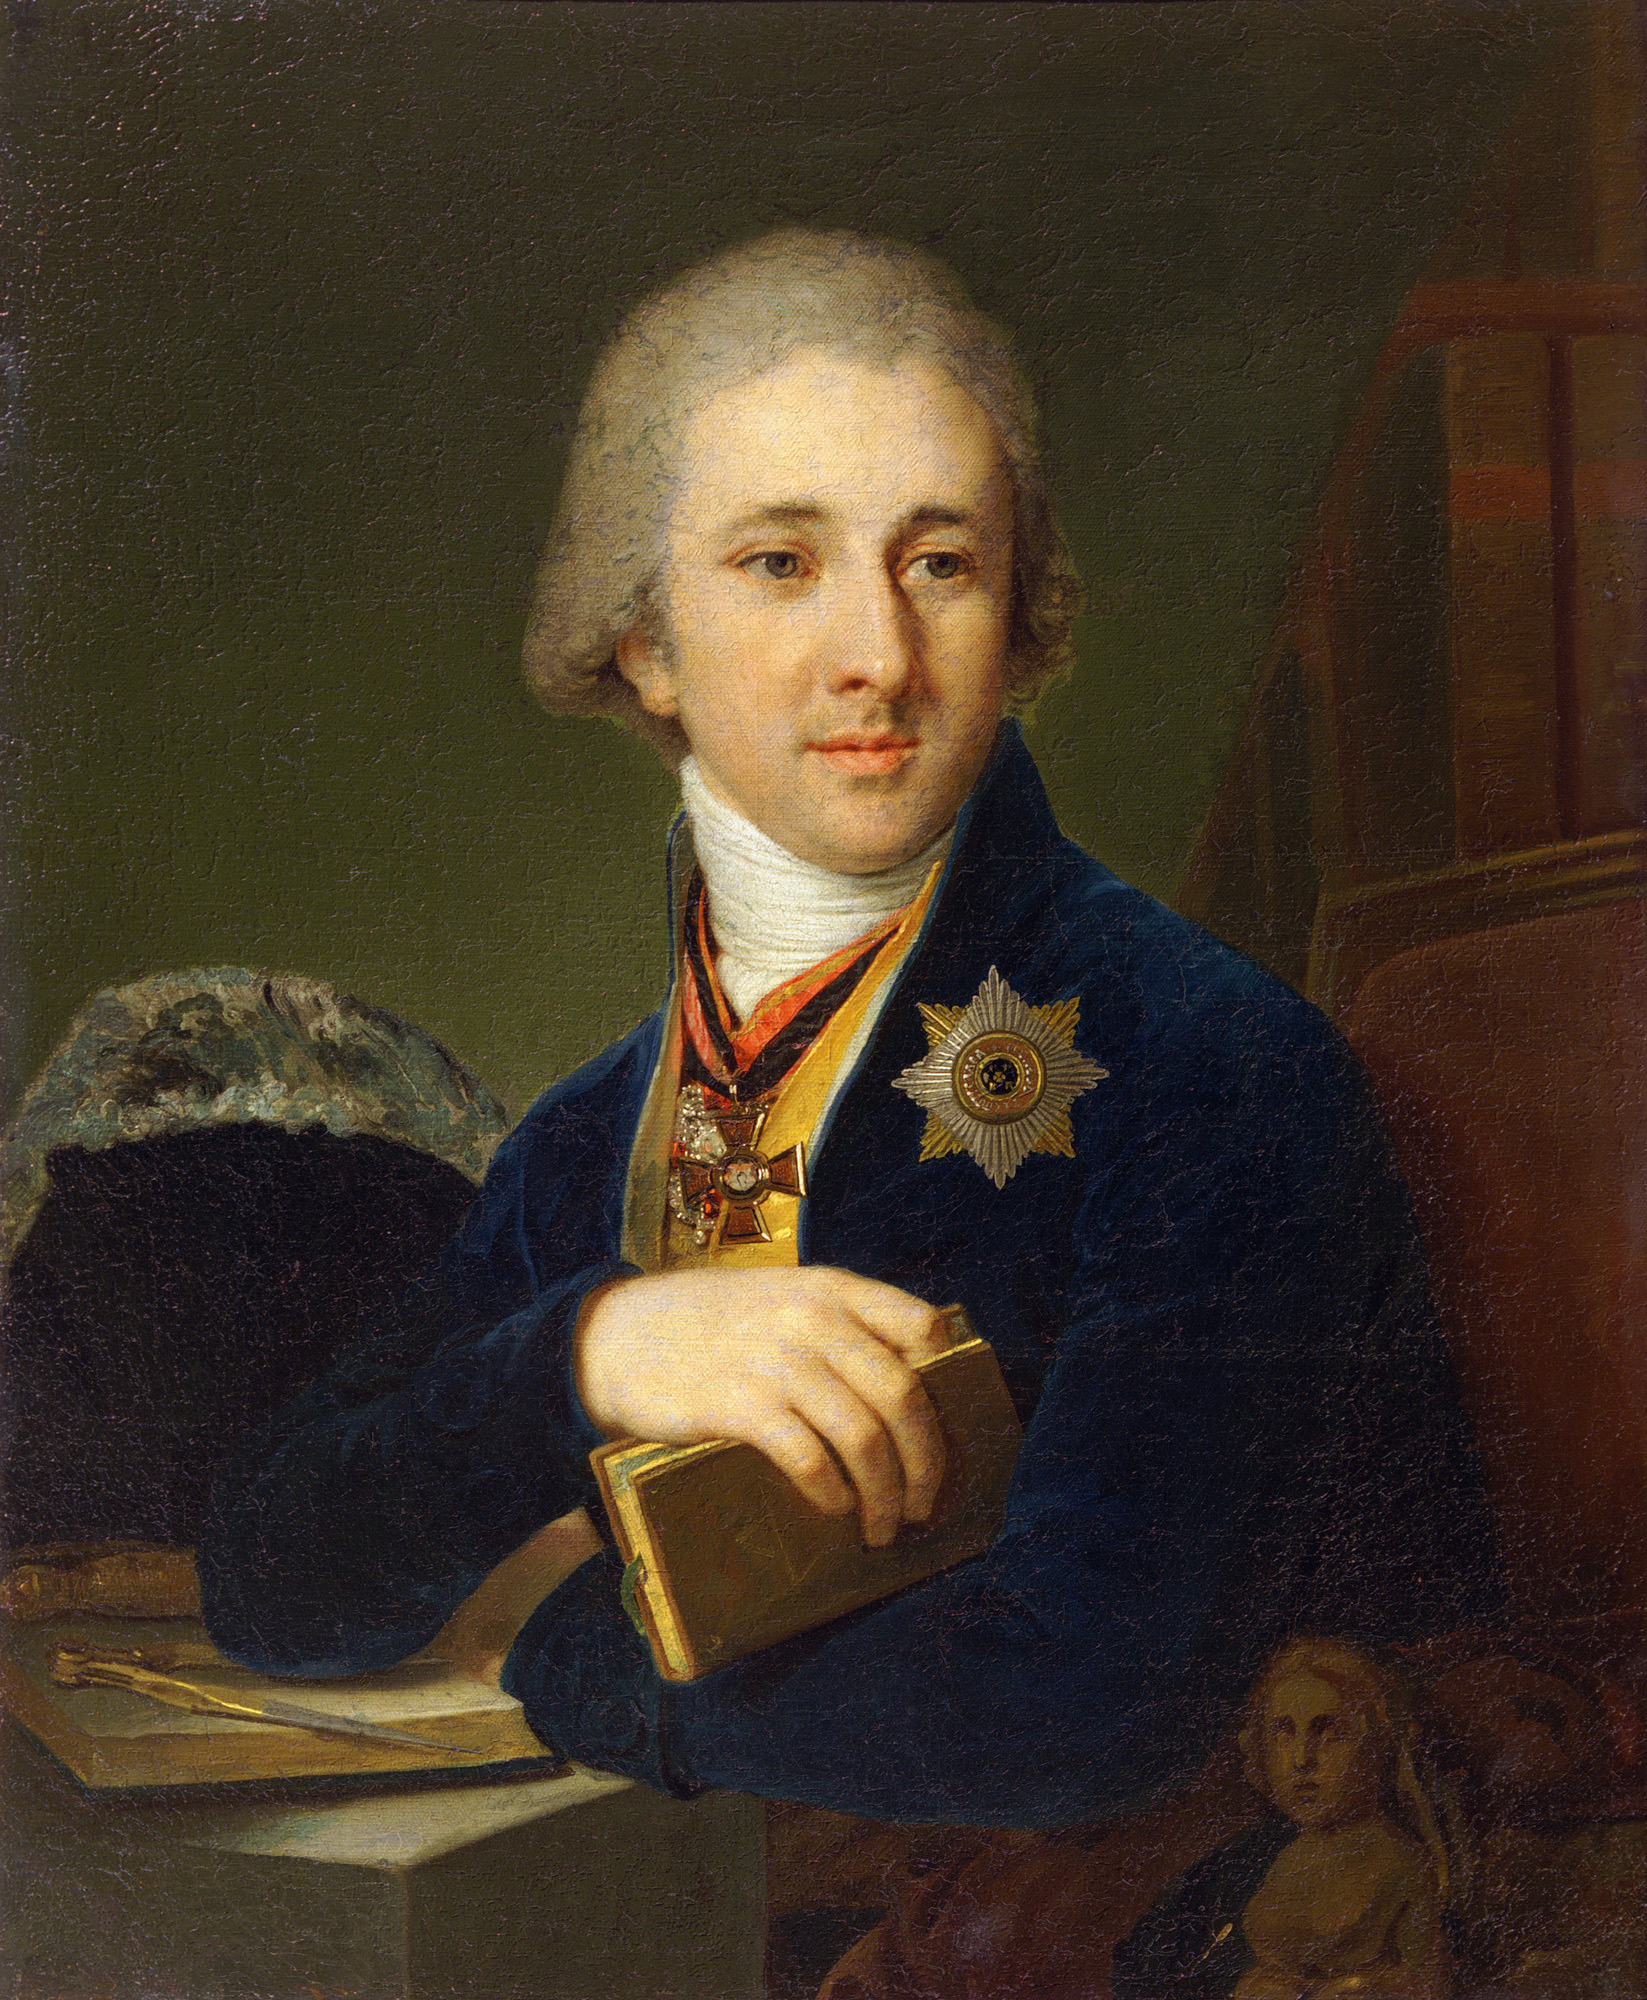What could the book in his hand signify about his persona? The book in the man's hand, along with his composed and introspective expression, suggests a persona deeply engaged in intellectual pursuits. During the 18th century, books in portraiture symbolized literacy, education, and scholarly engagement. They often indicated that the subject was a writer, thinker, or someone involved in academia or the arts. This association with a book subtly communicates that he values wisdom, knowledge, and intellectual discourse. 